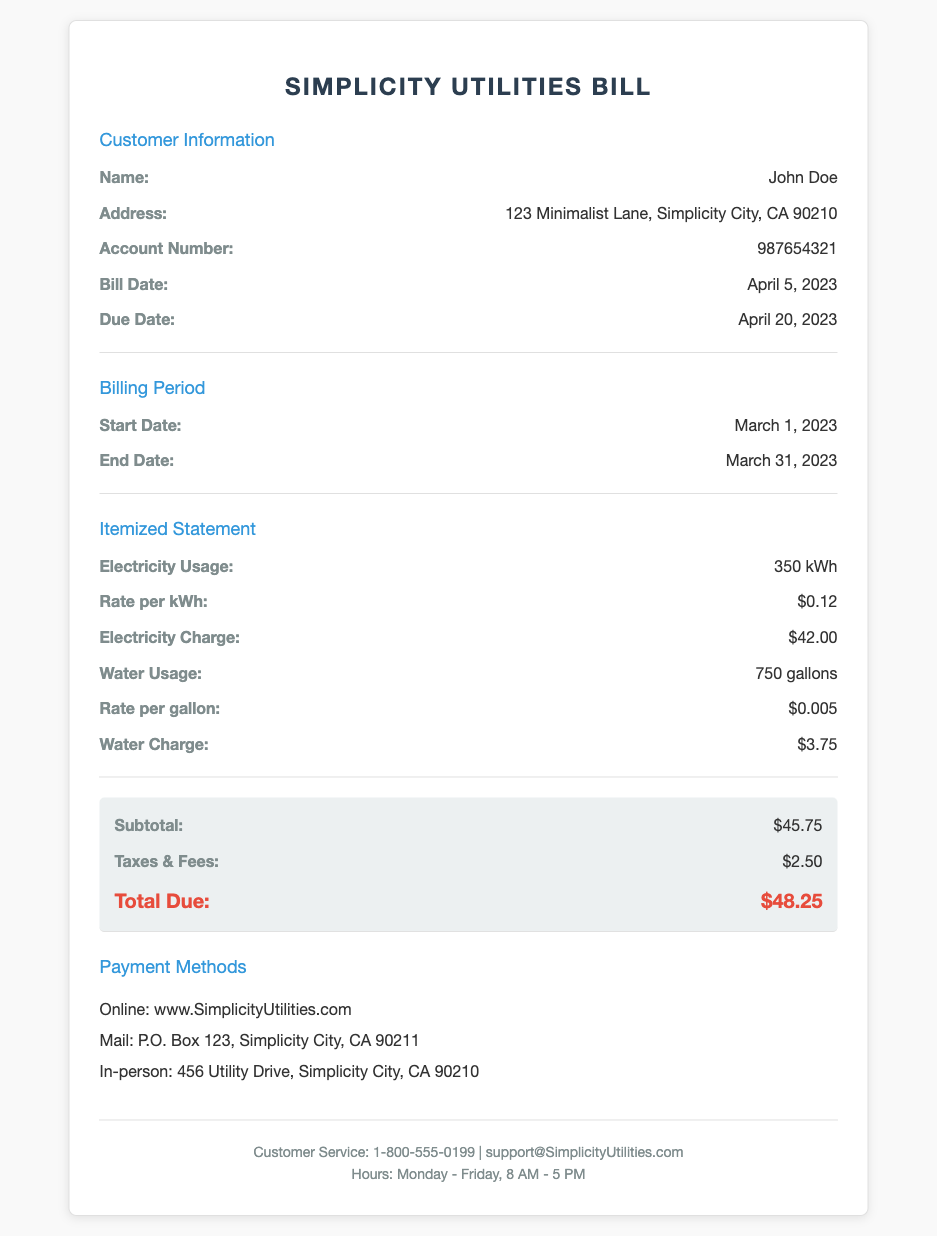What is the name of the customer? The document provides the customer's name under the Customer Information section.
Answer: John Doe What is the total due amount? The total due amount can be found in the summary section.
Answer: $48.25 What is the rate per kWh for electricity? The rate per kWh is specified in the itemized statement for electricity usage.
Answer: $0.12 How many gallons of water were used? The total water usage is mentioned in the itemized statement under Water Usage.
Answer: 750 gallons What is the bill date? The bill date is stated in the Customer Information section.
Answer: April 5, 2023 What is the subtotal before taxes and fees? The subtotal is listed in the summary section prior to any additional charges.
Answer: $45.75 What is the due date for the bill? The due date is found in the Customer Information section.
Answer: April 20, 2023 How much is the electricity charge? The electricity charge is shown in the itemized statement for electricity.
Answer: $42.00 What methods are available for payment? The payment methods are outlined in their own section in the document.
Answer: Online, Mail, In-person 